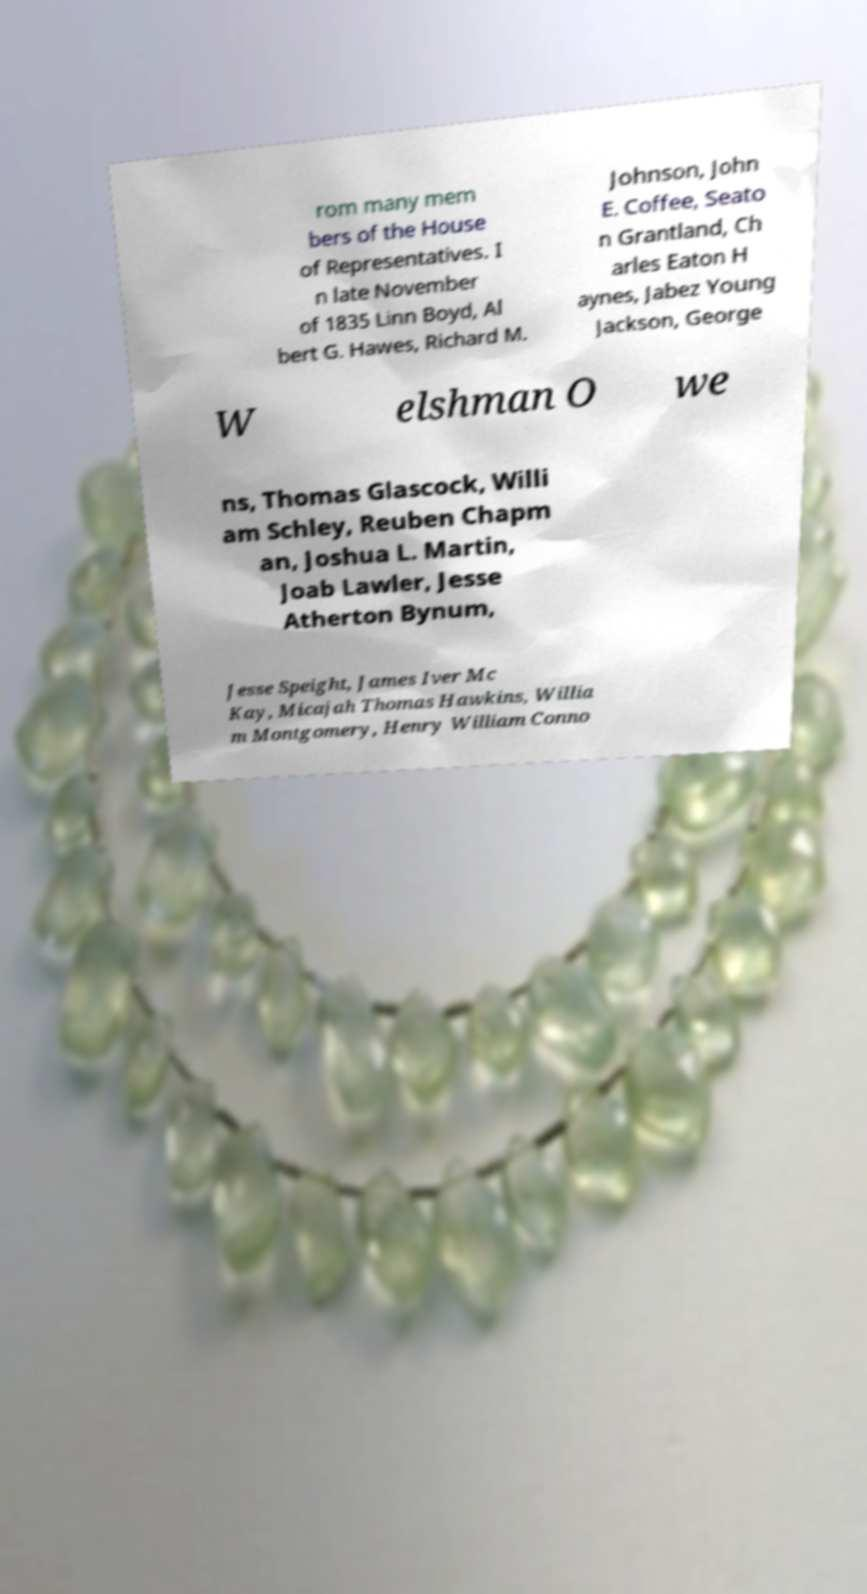There's text embedded in this image that I need extracted. Can you transcribe it verbatim? rom many mem bers of the House of Representatives. I n late November of 1835 Linn Boyd, Al bert G. Hawes, Richard M. Johnson, John E. Coffee, Seato n Grantland, Ch arles Eaton H aynes, Jabez Young Jackson, George W elshman O we ns, Thomas Glascock, Willi am Schley, Reuben Chapm an, Joshua L. Martin, Joab Lawler, Jesse Atherton Bynum, Jesse Speight, James Iver Mc Kay, Micajah Thomas Hawkins, Willia m Montgomery, Henry William Conno 